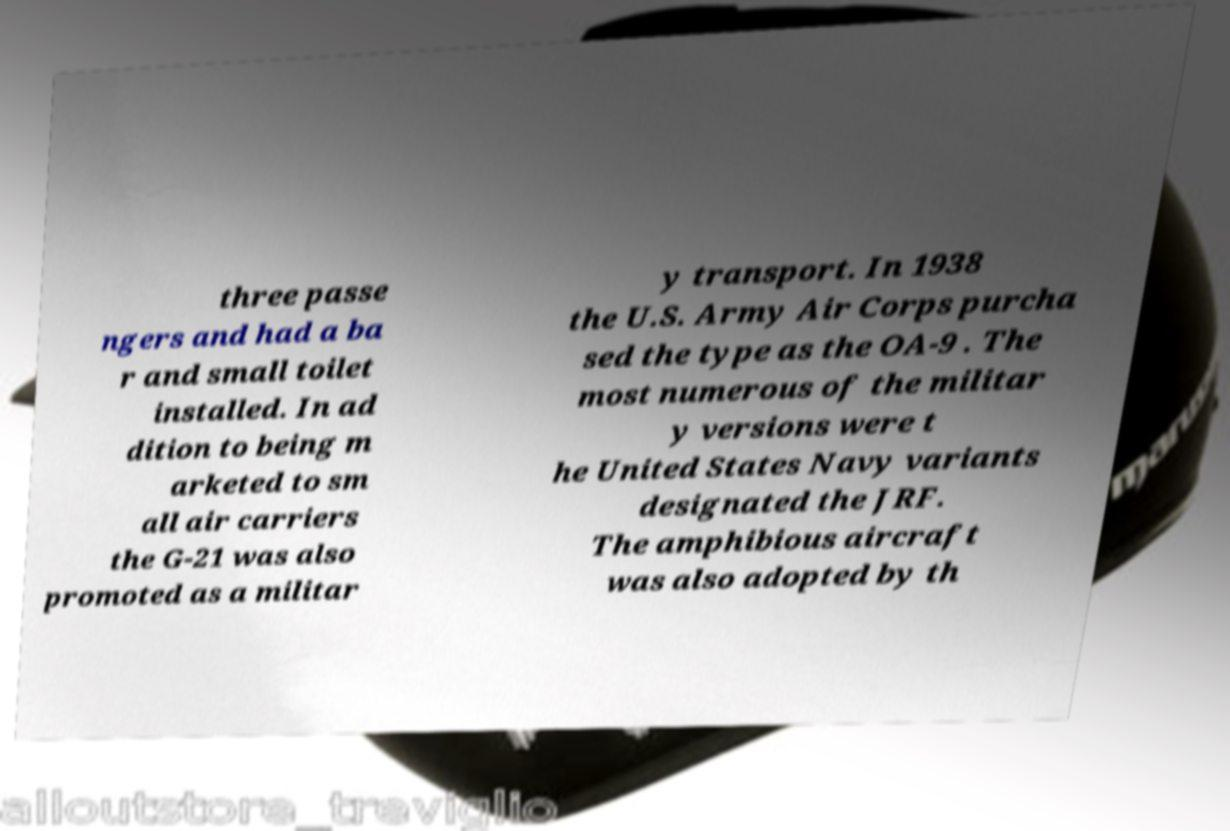There's text embedded in this image that I need extracted. Can you transcribe it verbatim? three passe ngers and had a ba r and small toilet installed. In ad dition to being m arketed to sm all air carriers the G-21 was also promoted as a militar y transport. In 1938 the U.S. Army Air Corps purcha sed the type as the OA-9 . The most numerous of the militar y versions were t he United States Navy variants designated the JRF. The amphibious aircraft was also adopted by th 